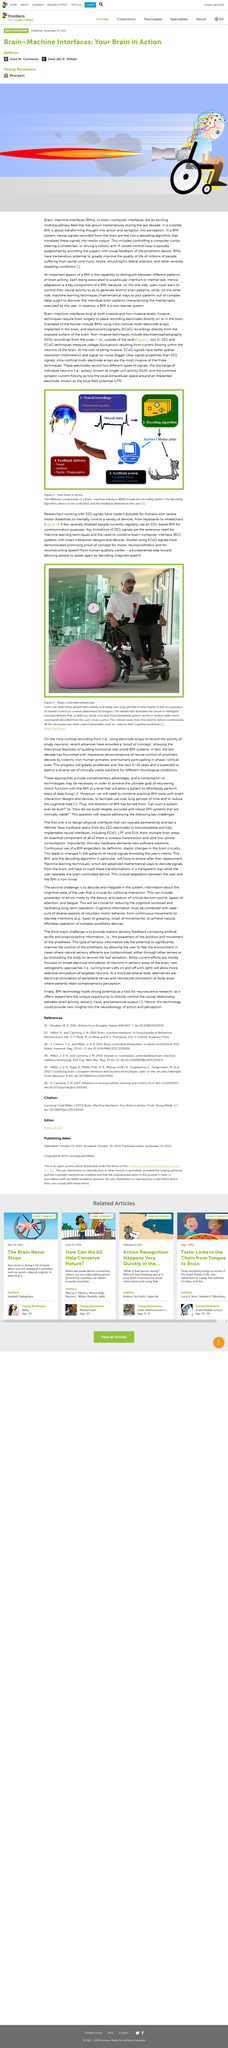Point out several critical features in this image. A decoding algorithm takes neural signals recorded from the brain and translates them into motor output, allowing for the simulation of movements through the body. Electrocorticography (ECoG) signal studies have provided evidence of the feasibility of motor neuroprosthetics. The acronym 'BMI' stands for brain-machine interfaces, while the acronym 'BRAIN' stands for 'bi-directional real-time adaptive integrative neural.' EEG signals have the potential to greatly benefit individuals with disabilities by enabling them to mentally control a variety of devices, such as keyboards and wheelchairs, through the use of advanced brain-computer interface technology. This not only enhances their mobility and independence, but also expands their ability to interact with and engage with their surroundings. The extensive use of machine learning techniques is a key limitation of using EEG signals. 